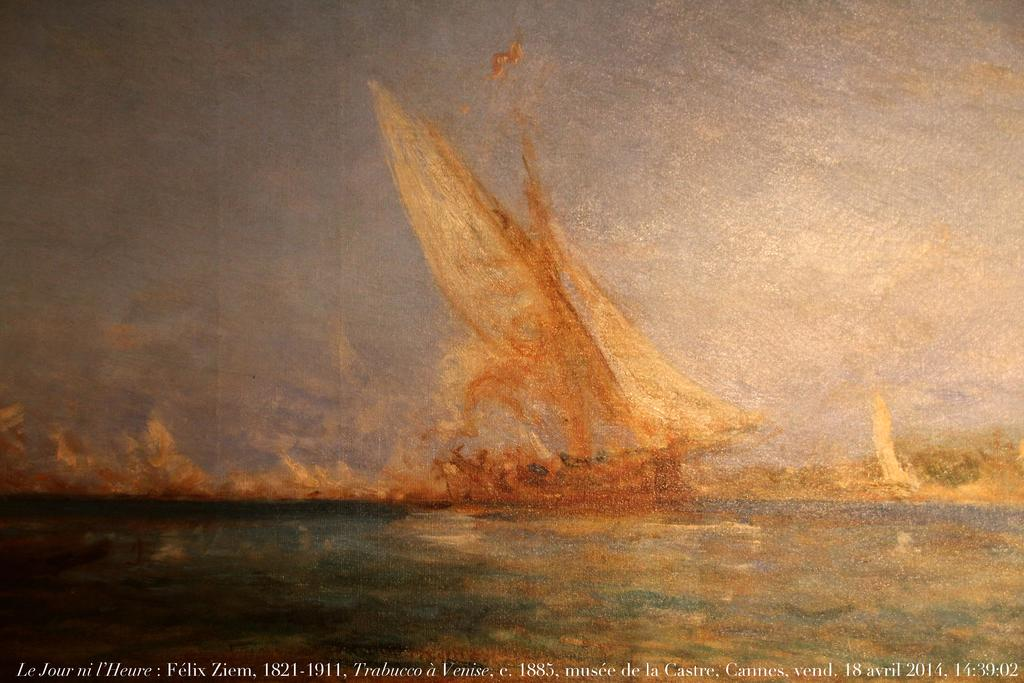<image>
Write a terse but informative summary of the picture. A photo of a painting that says 1821-1911 on the bottom. 